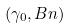<formula> <loc_0><loc_0><loc_500><loc_500>( \gamma _ { 0 } , B n )</formula> 